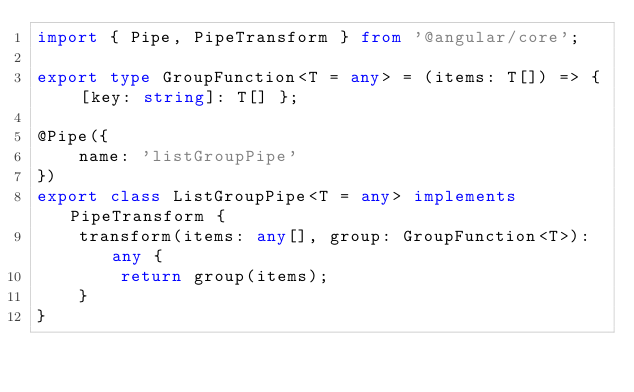<code> <loc_0><loc_0><loc_500><loc_500><_TypeScript_>import { Pipe, PipeTransform } from '@angular/core';

export type GroupFunction<T = any> = (items: T[]) => { [key: string]: T[] };

@Pipe({
    name: 'listGroupPipe'
})
export class ListGroupPipe<T = any> implements PipeTransform {
    transform(items: any[], group: GroupFunction<T>): any {
        return group(items);
    }
}
</code> 